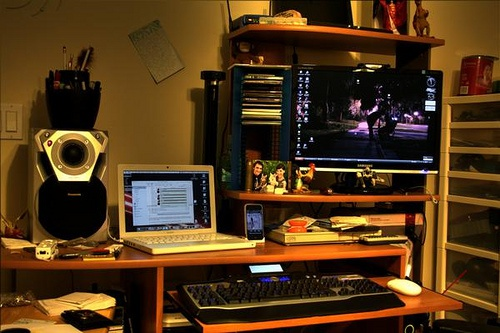Describe the objects in this image and their specific colors. I can see tv in black, gray, navy, and white tones, laptop in black, darkgray, and tan tones, keyboard in black, olive, and maroon tones, book in black, gold, maroon, olive, and orange tones, and cell phone in black, gray, and navy tones in this image. 